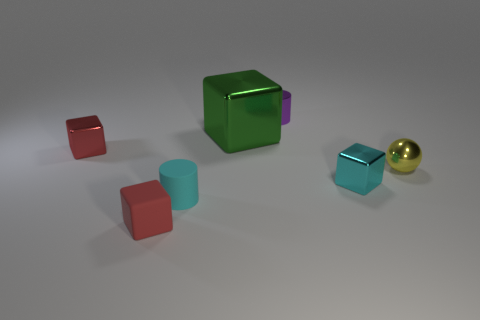Subtract all gray cubes. Subtract all blue spheres. How many cubes are left? 4 Add 2 green matte cylinders. How many objects exist? 9 Subtract all cylinders. How many objects are left? 5 Add 7 green objects. How many green objects are left? 8 Add 1 red rubber things. How many red rubber things exist? 2 Subtract 0 brown cubes. How many objects are left? 7 Subtract all large metal things. Subtract all tiny blue matte cylinders. How many objects are left? 6 